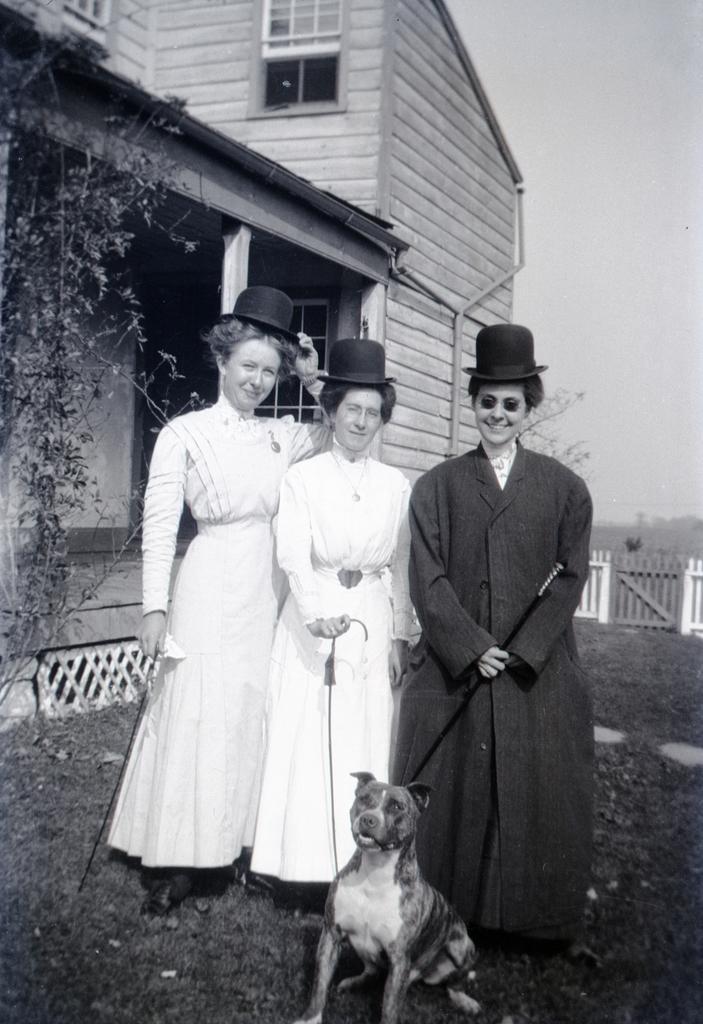How would you summarize this image in a sentence or two? In this image, we can see three women are standing and smiling. They are wearing hats and holding sticks. At the bottom, we can see a dog is sitting on the grass. Background we can see house, pillar, wall, windows, fencing, plant and sky. 